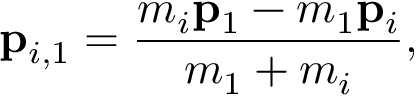<formula> <loc_0><loc_0><loc_500><loc_500>p _ { i , 1 } = \frac { m _ { i } p _ { 1 } - m _ { 1 } p _ { i } } { m _ { 1 } + m _ { i } } ,</formula> 